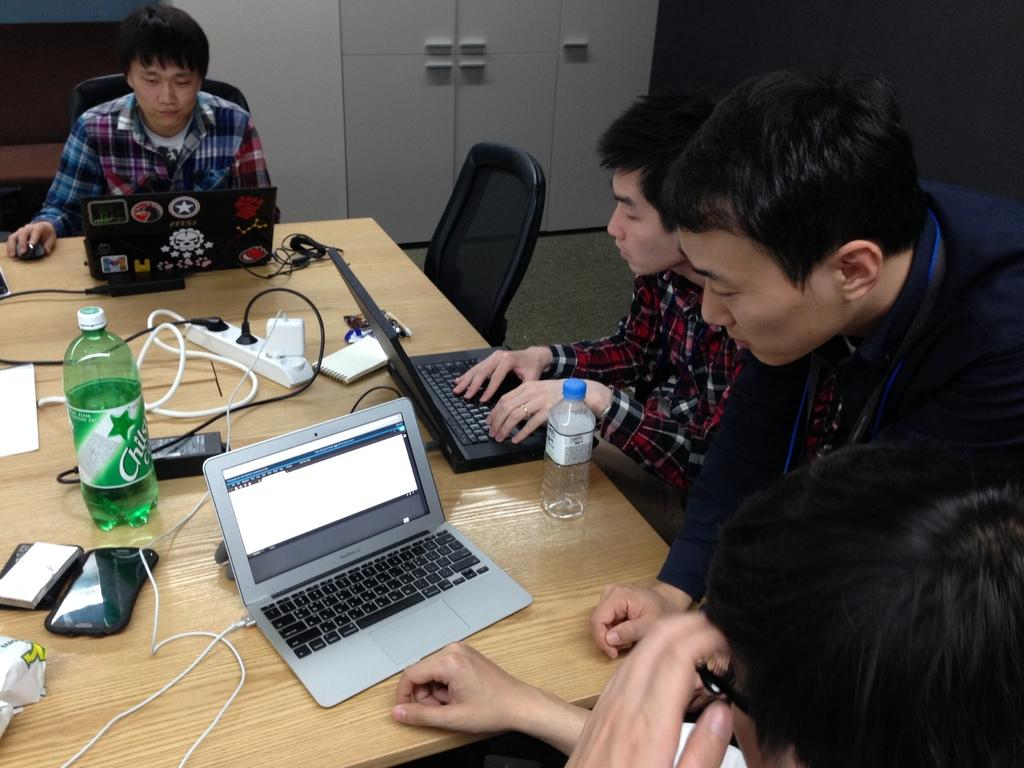What type of structure can be seen in the image? There is a wall in the image. Is there any entrance visible in the image? Yes, there is a door in the image. What are the people in the image doing? The people in the image are sitting on chairs. What is on the table in the image? There are laptops, a switch board, a book, a bottle, and a mobile phone on the table. What statement does the nation make in the image? There is no reference to a nation or any statements being made in the image. What type of cannon is present in the image? There is no cannon present in the image. 